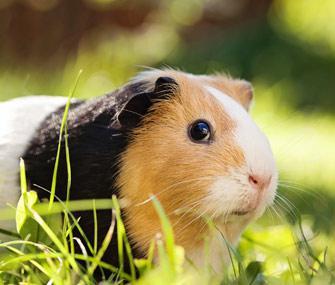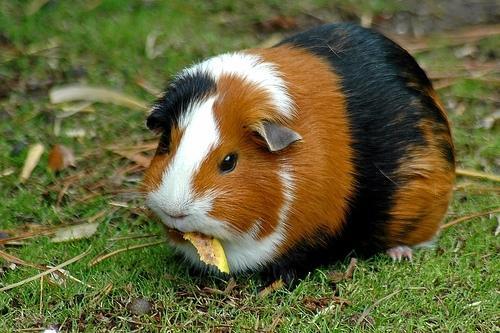The first image is the image on the left, the second image is the image on the right. Assess this claim about the two images: "One of the guinea pigs has patches of dark brown, black, and white fur.". Correct or not? Answer yes or no. Yes. 